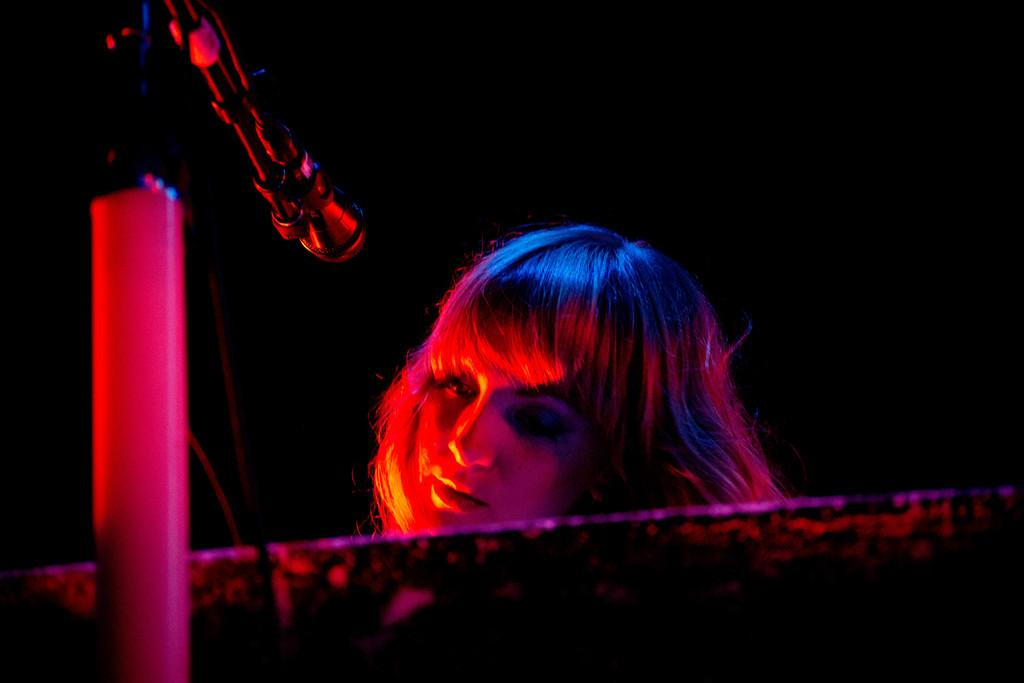Who is present in the image? There is a woman in the image. What object is visible in the image that is typically used for amplifying sound? There is a microphone (mic) in the image. What is the mic attached to in the image? There is a mic stand in the image. What type of trail can be seen in the image? There is no trail present in the image; it features a woman with a microphone and mic stand. 